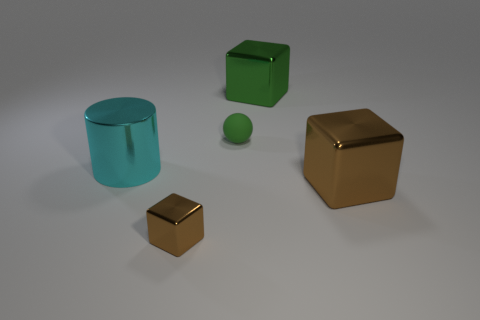Does the small shiny object have the same color as the small sphere? no 